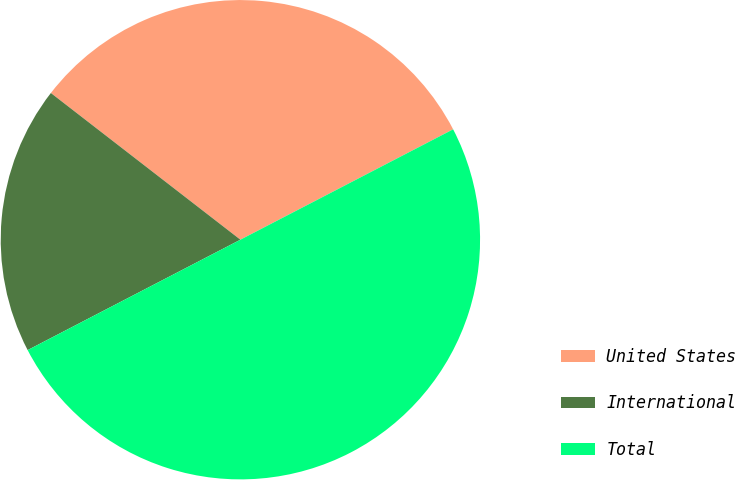Convert chart. <chart><loc_0><loc_0><loc_500><loc_500><pie_chart><fcel>United States<fcel>International<fcel>Total<nl><fcel>31.9%<fcel>18.1%<fcel>50.0%<nl></chart> 